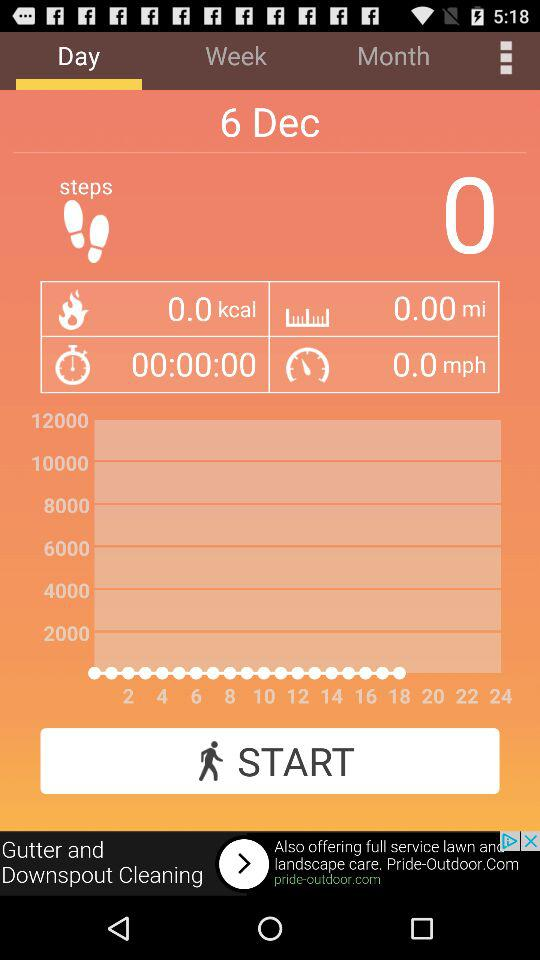How many steps in total are taken? Total steps taken are 0. 